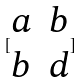<formula> <loc_0><loc_0><loc_500><loc_500>[ \begin{matrix} a & b \\ b & d \end{matrix} ]</formula> 